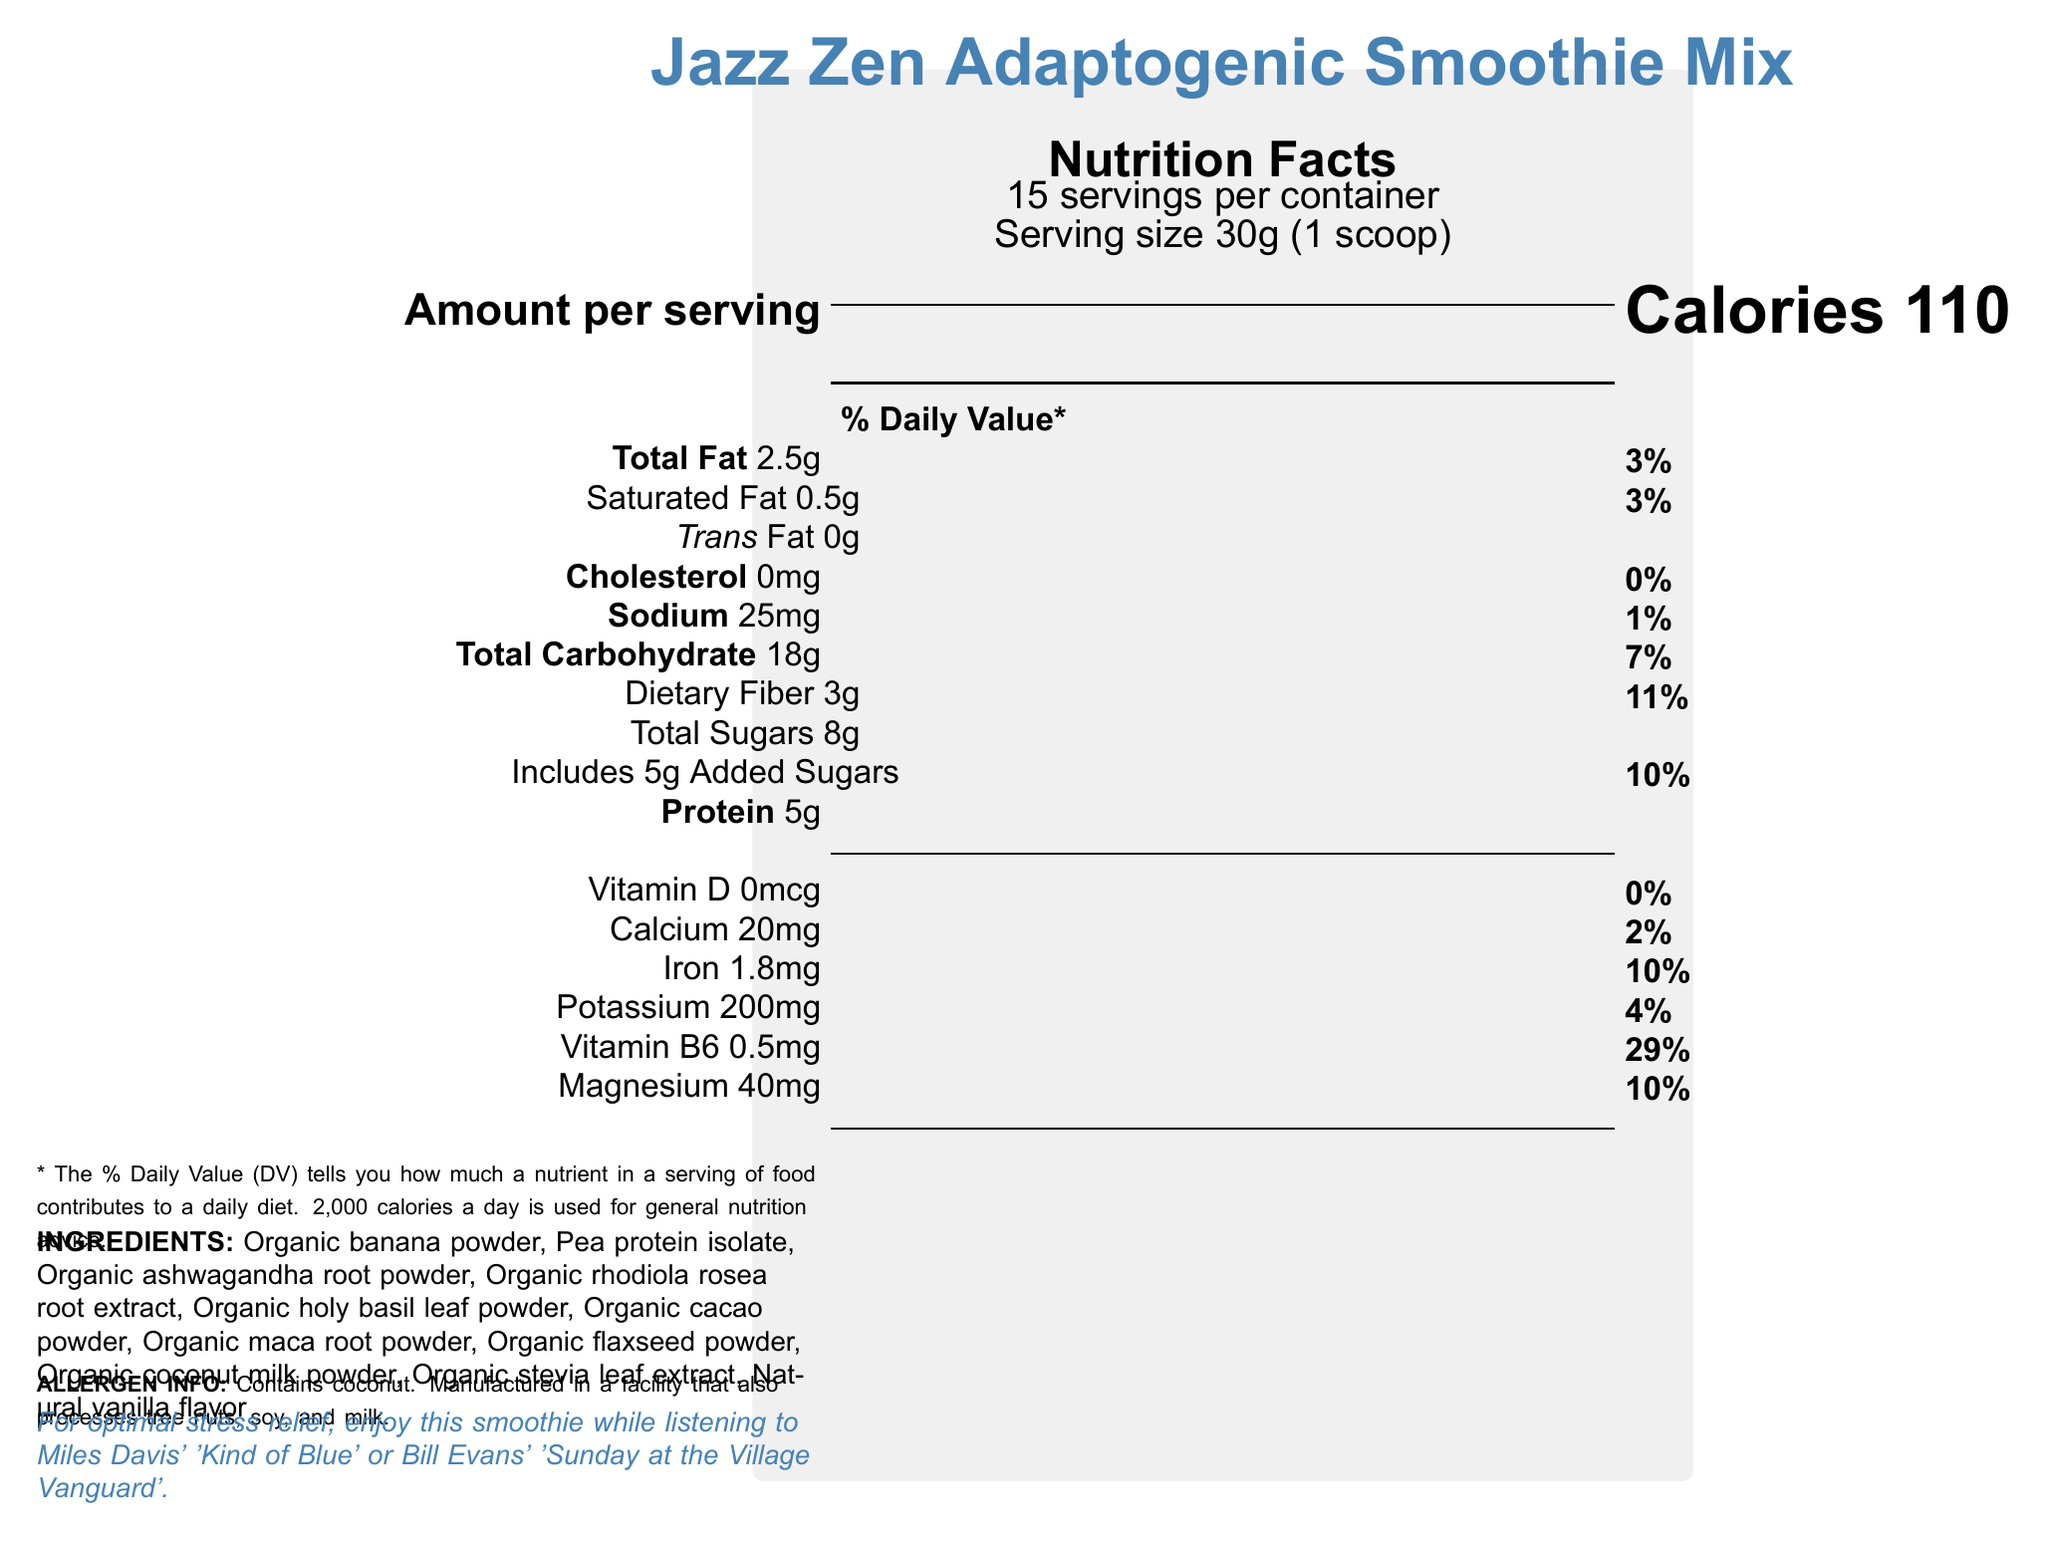what is the serving size? The serving size is explicitly mentioned in the document as 30g, which equals 1 scoop.
Answer: 30g (1 scoop) how many servings are there per container? The document states that there are 15 servings per container.
Answer: 15 how many calories are in one serving? The document clearly indicates that each serving contains 110 calories.
Answer: 110 what percentage of the daily value of protein does one serving provide? The document lists the amount of protein as 5g but does not provide the daily value percentage for protein.
Answer: Not listed what ingredients are included in the Jazz Zen Adaptogenic Smoothie Mix? The document provides a detailed list of all ingredients included in the smoothie mix.
Answer: Organic banana powder, Pea protein isolate, Organic ashwagandha root powder, Organic rhodiola rosea root extract, Organic holy basil leaf powder, Organic cacao powder, Organic maca root powder, Organic flaxseed powder, Organic coconut milk powder, Organic stevia leaf extract, Natural vanilla flavor what is the total amount of sugars in one serving? The total sugars per serving are listed as 8g in the document.
Answer: 8g Does this product contain any allergens? The allergen information notes that it contains coconut and is manufactured in a facility that processes tree nuts, soy, and milk.
Answer: Yes how much iron is in one serving, and what is its daily value percentage? The document states that one serving contains 1.8mg of iron, which is 10% of the daily value.
Answer: 1.8mg, 10% Based on the document, which of the following vitamins or minerals has the highest daily value percentage per serving? A. Vitamin D B. Calcium C. Vitamin B6 D. Magnesium The document lists Vitamin B6 with a daily value percentage of 29%, which is higher than the percentages for the other listed vitamins and minerals.
Answer: C. Vitamin B6 How much dietary fiber is in one serving of the smoothie mix? A. 1g B. 4g C. 3g D. 5g The document indicates that each serving contains 3g of dietary fiber.
Answer: C. 3g does this product contain any cholesterol? The document states that the product contains 0mg of cholesterol.
Answer: No summarize the main idea of the document. The document primarily provides comprehensive nutrition information about the Jazz Zen Adaptogenic Smoothie Mix, its health benefits, the ingredients used, and instructions on how to enjoy it optimally.
Answer: The Jazz Zen Adaptogenic Smoothie Mix is a stress-reducing beverage designed to be enjoyed while listening to jazz music. It contains adaptogenic herbs, plant-based protein, and various vitamins and minerals. The nutritional facts per serving include 110 calories, 2.5g of total fat, 18g of total carbohydrates, 3g of dietary fiber, and 8g of total sugars. It is recommended for its stress management and cognitive support benefits. The document also provides preparation instructions, storage advice, and disclaimers. what is the daily value percentage of magnesium per serving? The document lists the daily value percentage of magnesium as 10%.
Answer: 10% when should you enjoy this smoothie for optimal stress relief? A. While doing yoga B. During a morning walk C. While listening to jazz music D. Before sleeping The document suggests enjoying the smoothie while listening to jazz music for optimal stress relief.
Answer: C. While listening to jazz music does the document provide the cost of the smoothie mix? The document does not include any information regarding the cost of the smoothie mix.
Answer: Not enough information How is this product supposed to help with stress? The document states that the product contains adaptogenic herbs, which are known to help manage stress.
Answer: Contains adaptogenic herbs to help manage stress 